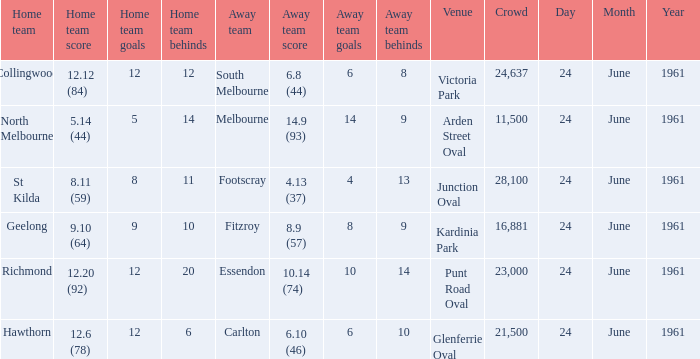What was the home team's score at the game attended by more than 24,637? 8.11 (59). 